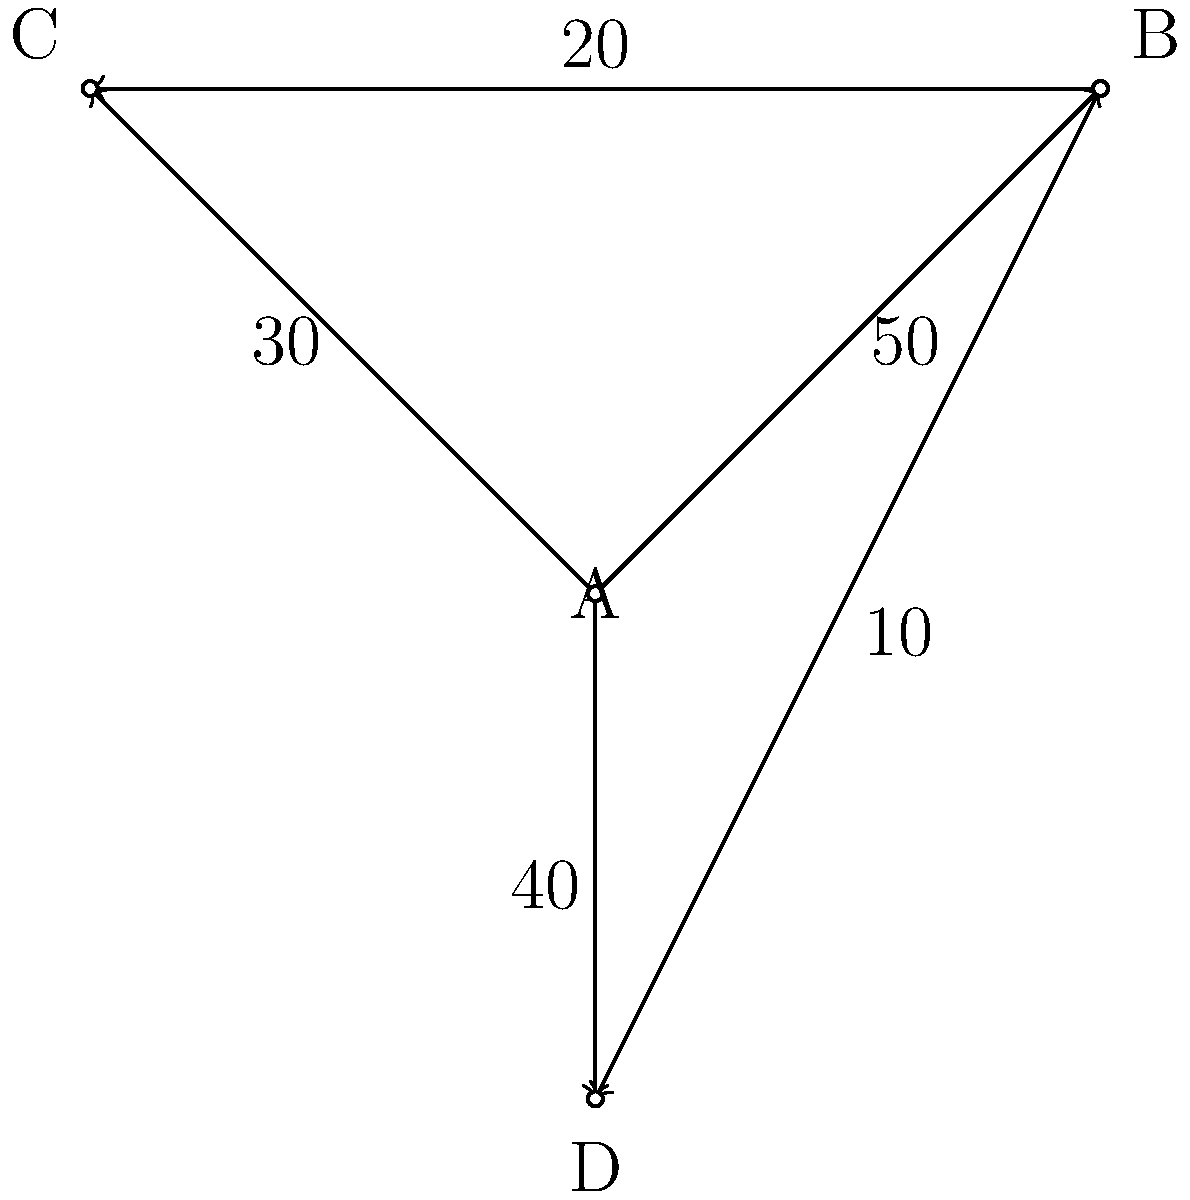In the given network diagram representing trade flows between countries A, B, C, and D, what is the total value of exports from country A to all other countries? To determine the total value of exports from country A to all other countries, we need to follow these steps:

1. Identify all arrows originating from country A:
   - A to B
   - A to C
   - A to D

2. Sum up the trade flow values associated with these arrows:
   - A to B: 50
   - A to C: 30
   - A to D: 40

3. Calculate the total:
   $50 + 30 + 40 = 120$

Therefore, the total value of exports from country A to all other countries is 120.
Answer: 120 